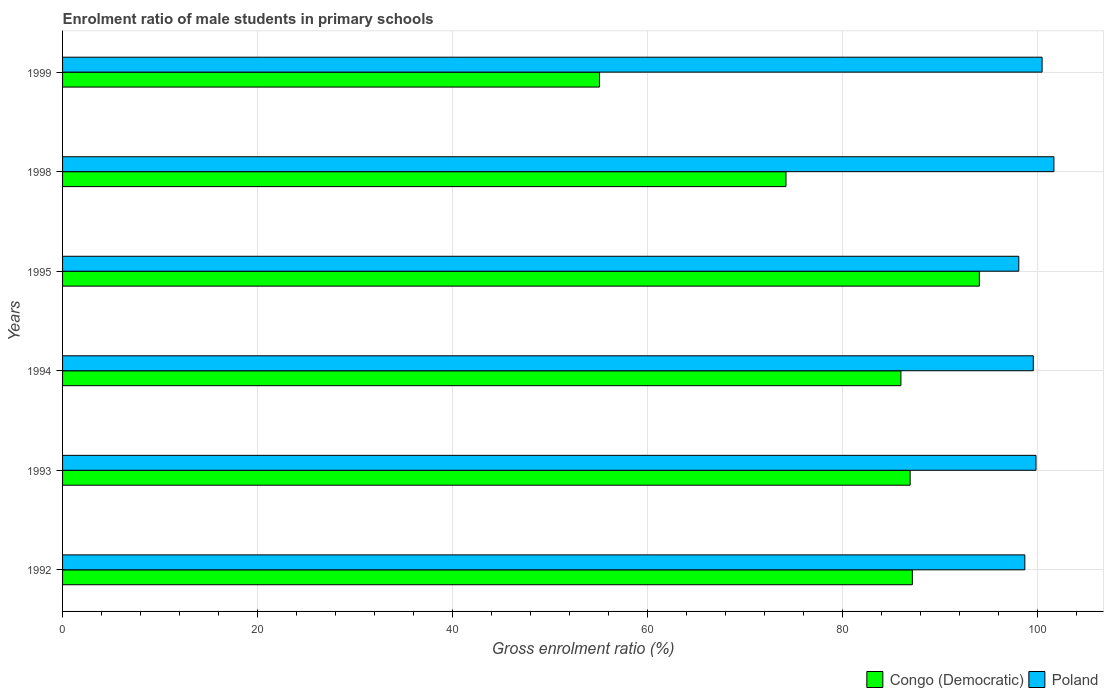How many different coloured bars are there?
Provide a succinct answer. 2. How many groups of bars are there?
Your response must be concise. 6. Are the number of bars on each tick of the Y-axis equal?
Make the answer very short. Yes. How many bars are there on the 4th tick from the top?
Your answer should be very brief. 2. How many bars are there on the 2nd tick from the bottom?
Your answer should be very brief. 2. In how many cases, is the number of bars for a given year not equal to the number of legend labels?
Provide a succinct answer. 0. What is the enrolment ratio of male students in primary schools in Congo (Democratic) in 1994?
Offer a very short reply. 85.99. Across all years, what is the maximum enrolment ratio of male students in primary schools in Congo (Democratic)?
Keep it short and to the point. 94.04. Across all years, what is the minimum enrolment ratio of male students in primary schools in Congo (Democratic)?
Keep it short and to the point. 55.07. In which year was the enrolment ratio of male students in primary schools in Poland minimum?
Your answer should be compact. 1995. What is the total enrolment ratio of male students in primary schools in Poland in the graph?
Provide a succinct answer. 598.36. What is the difference between the enrolment ratio of male students in primary schools in Congo (Democratic) in 1993 and that in 1998?
Make the answer very short. 12.73. What is the difference between the enrolment ratio of male students in primary schools in Congo (Democratic) in 1998 and the enrolment ratio of male students in primary schools in Poland in 1999?
Provide a succinct answer. -26.27. What is the average enrolment ratio of male students in primary schools in Poland per year?
Offer a very short reply. 99.73. In the year 1999, what is the difference between the enrolment ratio of male students in primary schools in Congo (Democratic) and enrolment ratio of male students in primary schools in Poland?
Provide a short and direct response. -45.4. In how many years, is the enrolment ratio of male students in primary schools in Poland greater than 24 %?
Offer a terse response. 6. What is the ratio of the enrolment ratio of male students in primary schools in Congo (Democratic) in 1995 to that in 1998?
Offer a very short reply. 1.27. Is the enrolment ratio of male students in primary schools in Congo (Democratic) in 1993 less than that in 1999?
Keep it short and to the point. No. Is the difference between the enrolment ratio of male students in primary schools in Congo (Democratic) in 1993 and 1998 greater than the difference between the enrolment ratio of male students in primary schools in Poland in 1993 and 1998?
Offer a very short reply. Yes. What is the difference between the highest and the second highest enrolment ratio of male students in primary schools in Congo (Democratic)?
Give a very brief answer. 6.87. What is the difference between the highest and the lowest enrolment ratio of male students in primary schools in Congo (Democratic)?
Provide a succinct answer. 38.97. In how many years, is the enrolment ratio of male students in primary schools in Poland greater than the average enrolment ratio of male students in primary schools in Poland taken over all years?
Give a very brief answer. 3. What does the 2nd bar from the top in 1999 represents?
Provide a short and direct response. Congo (Democratic). What does the 1st bar from the bottom in 1999 represents?
Your answer should be very brief. Congo (Democratic). How many bars are there?
Your answer should be compact. 12. Does the graph contain any zero values?
Provide a short and direct response. No. Does the graph contain grids?
Your response must be concise. Yes. How are the legend labels stacked?
Your response must be concise. Horizontal. What is the title of the graph?
Offer a very short reply. Enrolment ratio of male students in primary schools. What is the Gross enrolment ratio (%) of Congo (Democratic) in 1992?
Ensure brevity in your answer.  87.16. What is the Gross enrolment ratio (%) of Poland in 1992?
Give a very brief answer. 98.7. What is the Gross enrolment ratio (%) of Congo (Democratic) in 1993?
Provide a short and direct response. 86.94. What is the Gross enrolment ratio (%) of Poland in 1993?
Ensure brevity in your answer.  99.85. What is the Gross enrolment ratio (%) of Congo (Democratic) in 1994?
Ensure brevity in your answer.  85.99. What is the Gross enrolment ratio (%) in Poland in 1994?
Offer a terse response. 99.57. What is the Gross enrolment ratio (%) of Congo (Democratic) in 1995?
Make the answer very short. 94.04. What is the Gross enrolment ratio (%) in Poland in 1995?
Ensure brevity in your answer.  98.08. What is the Gross enrolment ratio (%) in Congo (Democratic) in 1998?
Your response must be concise. 74.2. What is the Gross enrolment ratio (%) of Poland in 1998?
Provide a succinct answer. 101.69. What is the Gross enrolment ratio (%) of Congo (Democratic) in 1999?
Give a very brief answer. 55.07. What is the Gross enrolment ratio (%) of Poland in 1999?
Your answer should be compact. 100.47. Across all years, what is the maximum Gross enrolment ratio (%) in Congo (Democratic)?
Offer a very short reply. 94.04. Across all years, what is the maximum Gross enrolment ratio (%) of Poland?
Offer a very short reply. 101.69. Across all years, what is the minimum Gross enrolment ratio (%) of Congo (Democratic)?
Provide a succinct answer. 55.07. Across all years, what is the minimum Gross enrolment ratio (%) in Poland?
Ensure brevity in your answer.  98.08. What is the total Gross enrolment ratio (%) of Congo (Democratic) in the graph?
Offer a very short reply. 483.4. What is the total Gross enrolment ratio (%) of Poland in the graph?
Your response must be concise. 598.36. What is the difference between the Gross enrolment ratio (%) in Congo (Democratic) in 1992 and that in 1993?
Offer a terse response. 0.23. What is the difference between the Gross enrolment ratio (%) in Poland in 1992 and that in 1993?
Provide a succinct answer. -1.15. What is the difference between the Gross enrolment ratio (%) of Congo (Democratic) in 1992 and that in 1994?
Your answer should be very brief. 1.17. What is the difference between the Gross enrolment ratio (%) in Poland in 1992 and that in 1994?
Offer a terse response. -0.87. What is the difference between the Gross enrolment ratio (%) of Congo (Democratic) in 1992 and that in 1995?
Your answer should be compact. -6.87. What is the difference between the Gross enrolment ratio (%) of Poland in 1992 and that in 1995?
Offer a very short reply. 0.62. What is the difference between the Gross enrolment ratio (%) of Congo (Democratic) in 1992 and that in 1998?
Your answer should be very brief. 12.96. What is the difference between the Gross enrolment ratio (%) of Poland in 1992 and that in 1998?
Provide a succinct answer. -2.98. What is the difference between the Gross enrolment ratio (%) in Congo (Democratic) in 1992 and that in 1999?
Provide a short and direct response. 32.09. What is the difference between the Gross enrolment ratio (%) in Poland in 1992 and that in 1999?
Provide a short and direct response. -1.77. What is the difference between the Gross enrolment ratio (%) in Congo (Democratic) in 1993 and that in 1994?
Give a very brief answer. 0.95. What is the difference between the Gross enrolment ratio (%) of Poland in 1993 and that in 1994?
Ensure brevity in your answer.  0.28. What is the difference between the Gross enrolment ratio (%) in Poland in 1993 and that in 1995?
Provide a short and direct response. 1.77. What is the difference between the Gross enrolment ratio (%) in Congo (Democratic) in 1993 and that in 1998?
Ensure brevity in your answer.  12.73. What is the difference between the Gross enrolment ratio (%) in Poland in 1993 and that in 1998?
Ensure brevity in your answer.  -1.84. What is the difference between the Gross enrolment ratio (%) of Congo (Democratic) in 1993 and that in 1999?
Make the answer very short. 31.87. What is the difference between the Gross enrolment ratio (%) in Poland in 1993 and that in 1999?
Keep it short and to the point. -0.63. What is the difference between the Gross enrolment ratio (%) of Congo (Democratic) in 1994 and that in 1995?
Your response must be concise. -8.05. What is the difference between the Gross enrolment ratio (%) in Poland in 1994 and that in 1995?
Your response must be concise. 1.49. What is the difference between the Gross enrolment ratio (%) in Congo (Democratic) in 1994 and that in 1998?
Make the answer very short. 11.79. What is the difference between the Gross enrolment ratio (%) in Poland in 1994 and that in 1998?
Offer a very short reply. -2.12. What is the difference between the Gross enrolment ratio (%) of Congo (Democratic) in 1994 and that in 1999?
Provide a succinct answer. 30.92. What is the difference between the Gross enrolment ratio (%) of Poland in 1994 and that in 1999?
Provide a short and direct response. -0.9. What is the difference between the Gross enrolment ratio (%) of Congo (Democratic) in 1995 and that in 1998?
Provide a succinct answer. 19.83. What is the difference between the Gross enrolment ratio (%) of Poland in 1995 and that in 1998?
Provide a short and direct response. -3.6. What is the difference between the Gross enrolment ratio (%) of Congo (Democratic) in 1995 and that in 1999?
Provide a short and direct response. 38.97. What is the difference between the Gross enrolment ratio (%) of Poland in 1995 and that in 1999?
Keep it short and to the point. -2.39. What is the difference between the Gross enrolment ratio (%) of Congo (Democratic) in 1998 and that in 1999?
Provide a short and direct response. 19.13. What is the difference between the Gross enrolment ratio (%) in Poland in 1998 and that in 1999?
Give a very brief answer. 1.21. What is the difference between the Gross enrolment ratio (%) in Congo (Democratic) in 1992 and the Gross enrolment ratio (%) in Poland in 1993?
Keep it short and to the point. -12.68. What is the difference between the Gross enrolment ratio (%) of Congo (Democratic) in 1992 and the Gross enrolment ratio (%) of Poland in 1994?
Ensure brevity in your answer.  -12.41. What is the difference between the Gross enrolment ratio (%) of Congo (Democratic) in 1992 and the Gross enrolment ratio (%) of Poland in 1995?
Your response must be concise. -10.92. What is the difference between the Gross enrolment ratio (%) of Congo (Democratic) in 1992 and the Gross enrolment ratio (%) of Poland in 1998?
Keep it short and to the point. -14.52. What is the difference between the Gross enrolment ratio (%) in Congo (Democratic) in 1992 and the Gross enrolment ratio (%) in Poland in 1999?
Your response must be concise. -13.31. What is the difference between the Gross enrolment ratio (%) of Congo (Democratic) in 1993 and the Gross enrolment ratio (%) of Poland in 1994?
Your response must be concise. -12.63. What is the difference between the Gross enrolment ratio (%) of Congo (Democratic) in 1993 and the Gross enrolment ratio (%) of Poland in 1995?
Your answer should be very brief. -11.15. What is the difference between the Gross enrolment ratio (%) in Congo (Democratic) in 1993 and the Gross enrolment ratio (%) in Poland in 1998?
Your answer should be very brief. -14.75. What is the difference between the Gross enrolment ratio (%) in Congo (Democratic) in 1993 and the Gross enrolment ratio (%) in Poland in 1999?
Offer a terse response. -13.54. What is the difference between the Gross enrolment ratio (%) in Congo (Democratic) in 1994 and the Gross enrolment ratio (%) in Poland in 1995?
Give a very brief answer. -12.09. What is the difference between the Gross enrolment ratio (%) of Congo (Democratic) in 1994 and the Gross enrolment ratio (%) of Poland in 1998?
Provide a succinct answer. -15.7. What is the difference between the Gross enrolment ratio (%) in Congo (Democratic) in 1994 and the Gross enrolment ratio (%) in Poland in 1999?
Provide a short and direct response. -14.48. What is the difference between the Gross enrolment ratio (%) in Congo (Democratic) in 1995 and the Gross enrolment ratio (%) in Poland in 1998?
Your answer should be very brief. -7.65. What is the difference between the Gross enrolment ratio (%) in Congo (Democratic) in 1995 and the Gross enrolment ratio (%) in Poland in 1999?
Ensure brevity in your answer.  -6.44. What is the difference between the Gross enrolment ratio (%) of Congo (Democratic) in 1998 and the Gross enrolment ratio (%) of Poland in 1999?
Keep it short and to the point. -26.27. What is the average Gross enrolment ratio (%) of Congo (Democratic) per year?
Give a very brief answer. 80.57. What is the average Gross enrolment ratio (%) in Poland per year?
Give a very brief answer. 99.73. In the year 1992, what is the difference between the Gross enrolment ratio (%) of Congo (Democratic) and Gross enrolment ratio (%) of Poland?
Your answer should be compact. -11.54. In the year 1993, what is the difference between the Gross enrolment ratio (%) in Congo (Democratic) and Gross enrolment ratio (%) in Poland?
Your answer should be compact. -12.91. In the year 1994, what is the difference between the Gross enrolment ratio (%) in Congo (Democratic) and Gross enrolment ratio (%) in Poland?
Your answer should be very brief. -13.58. In the year 1995, what is the difference between the Gross enrolment ratio (%) in Congo (Democratic) and Gross enrolment ratio (%) in Poland?
Your response must be concise. -4.05. In the year 1998, what is the difference between the Gross enrolment ratio (%) of Congo (Democratic) and Gross enrolment ratio (%) of Poland?
Offer a terse response. -27.48. In the year 1999, what is the difference between the Gross enrolment ratio (%) in Congo (Democratic) and Gross enrolment ratio (%) in Poland?
Your response must be concise. -45.4. What is the ratio of the Gross enrolment ratio (%) in Congo (Democratic) in 1992 to that in 1994?
Offer a terse response. 1.01. What is the ratio of the Gross enrolment ratio (%) in Congo (Democratic) in 1992 to that in 1995?
Offer a very short reply. 0.93. What is the ratio of the Gross enrolment ratio (%) of Poland in 1992 to that in 1995?
Make the answer very short. 1.01. What is the ratio of the Gross enrolment ratio (%) in Congo (Democratic) in 1992 to that in 1998?
Keep it short and to the point. 1.17. What is the ratio of the Gross enrolment ratio (%) of Poland in 1992 to that in 1998?
Your answer should be compact. 0.97. What is the ratio of the Gross enrolment ratio (%) of Congo (Democratic) in 1992 to that in 1999?
Provide a succinct answer. 1.58. What is the ratio of the Gross enrolment ratio (%) of Poland in 1992 to that in 1999?
Provide a succinct answer. 0.98. What is the ratio of the Gross enrolment ratio (%) of Congo (Democratic) in 1993 to that in 1994?
Keep it short and to the point. 1.01. What is the ratio of the Gross enrolment ratio (%) in Congo (Democratic) in 1993 to that in 1995?
Offer a terse response. 0.92. What is the ratio of the Gross enrolment ratio (%) of Poland in 1993 to that in 1995?
Your response must be concise. 1.02. What is the ratio of the Gross enrolment ratio (%) in Congo (Democratic) in 1993 to that in 1998?
Offer a terse response. 1.17. What is the ratio of the Gross enrolment ratio (%) of Poland in 1993 to that in 1998?
Offer a terse response. 0.98. What is the ratio of the Gross enrolment ratio (%) in Congo (Democratic) in 1993 to that in 1999?
Your answer should be compact. 1.58. What is the ratio of the Gross enrolment ratio (%) of Poland in 1993 to that in 1999?
Your answer should be very brief. 0.99. What is the ratio of the Gross enrolment ratio (%) in Congo (Democratic) in 1994 to that in 1995?
Make the answer very short. 0.91. What is the ratio of the Gross enrolment ratio (%) in Poland in 1994 to that in 1995?
Make the answer very short. 1.02. What is the ratio of the Gross enrolment ratio (%) in Congo (Democratic) in 1994 to that in 1998?
Make the answer very short. 1.16. What is the ratio of the Gross enrolment ratio (%) of Poland in 1994 to that in 1998?
Offer a terse response. 0.98. What is the ratio of the Gross enrolment ratio (%) of Congo (Democratic) in 1994 to that in 1999?
Provide a succinct answer. 1.56. What is the ratio of the Gross enrolment ratio (%) of Poland in 1994 to that in 1999?
Your answer should be compact. 0.99. What is the ratio of the Gross enrolment ratio (%) of Congo (Democratic) in 1995 to that in 1998?
Provide a short and direct response. 1.27. What is the ratio of the Gross enrolment ratio (%) in Poland in 1995 to that in 1998?
Keep it short and to the point. 0.96. What is the ratio of the Gross enrolment ratio (%) in Congo (Democratic) in 1995 to that in 1999?
Make the answer very short. 1.71. What is the ratio of the Gross enrolment ratio (%) in Poland in 1995 to that in 1999?
Your answer should be very brief. 0.98. What is the ratio of the Gross enrolment ratio (%) of Congo (Democratic) in 1998 to that in 1999?
Your response must be concise. 1.35. What is the ratio of the Gross enrolment ratio (%) of Poland in 1998 to that in 1999?
Your answer should be compact. 1.01. What is the difference between the highest and the second highest Gross enrolment ratio (%) of Congo (Democratic)?
Your answer should be very brief. 6.87. What is the difference between the highest and the second highest Gross enrolment ratio (%) in Poland?
Your answer should be compact. 1.21. What is the difference between the highest and the lowest Gross enrolment ratio (%) of Congo (Democratic)?
Offer a very short reply. 38.97. What is the difference between the highest and the lowest Gross enrolment ratio (%) in Poland?
Provide a succinct answer. 3.6. 